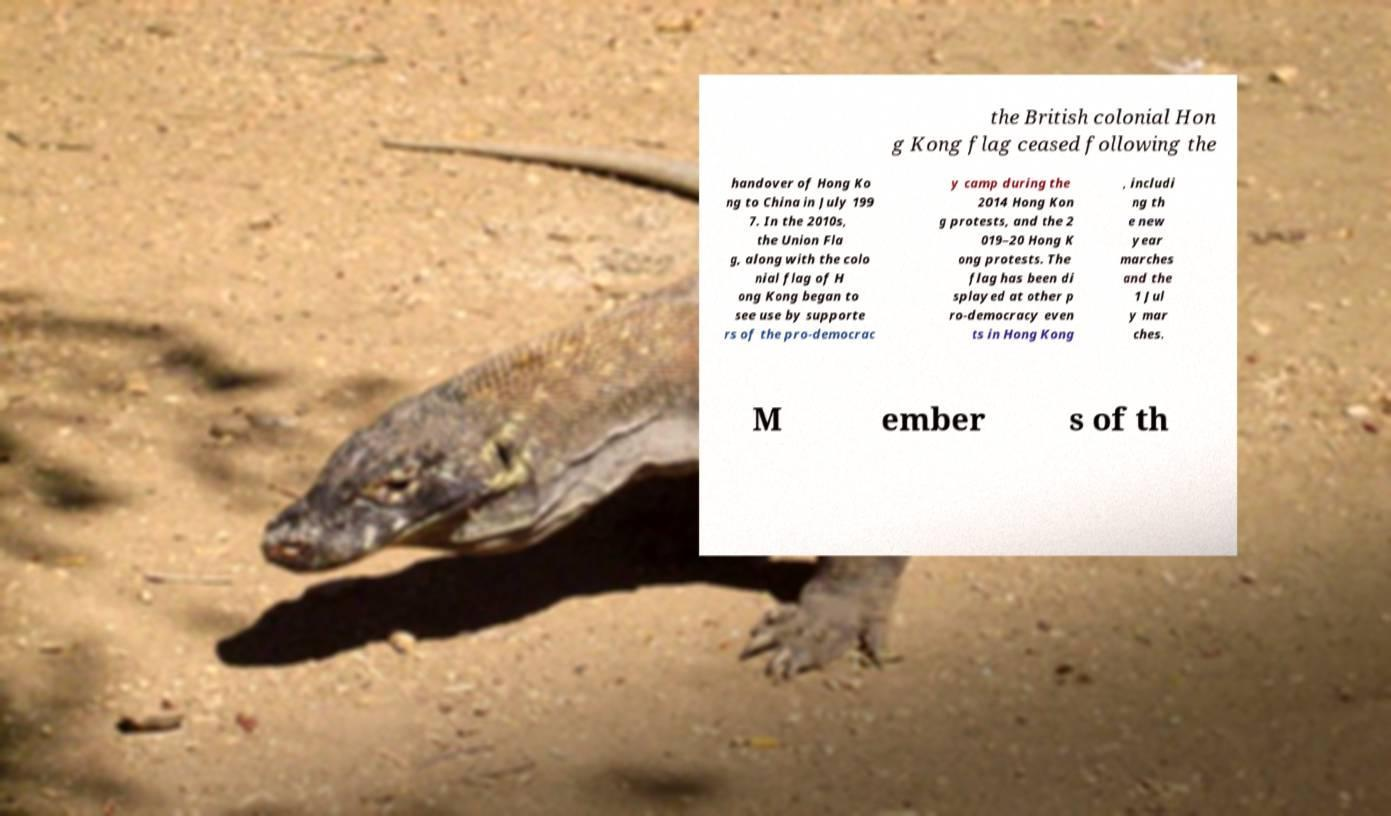There's text embedded in this image that I need extracted. Can you transcribe it verbatim? the British colonial Hon g Kong flag ceased following the handover of Hong Ko ng to China in July 199 7. In the 2010s, the Union Fla g, along with the colo nial flag of H ong Kong began to see use by supporte rs of the pro-democrac y camp during the 2014 Hong Kon g protests, and the 2 019–20 Hong K ong protests. The flag has been di splayed at other p ro-democracy even ts in Hong Kong , includi ng th e new year marches and the 1 Jul y mar ches. M ember s of th 